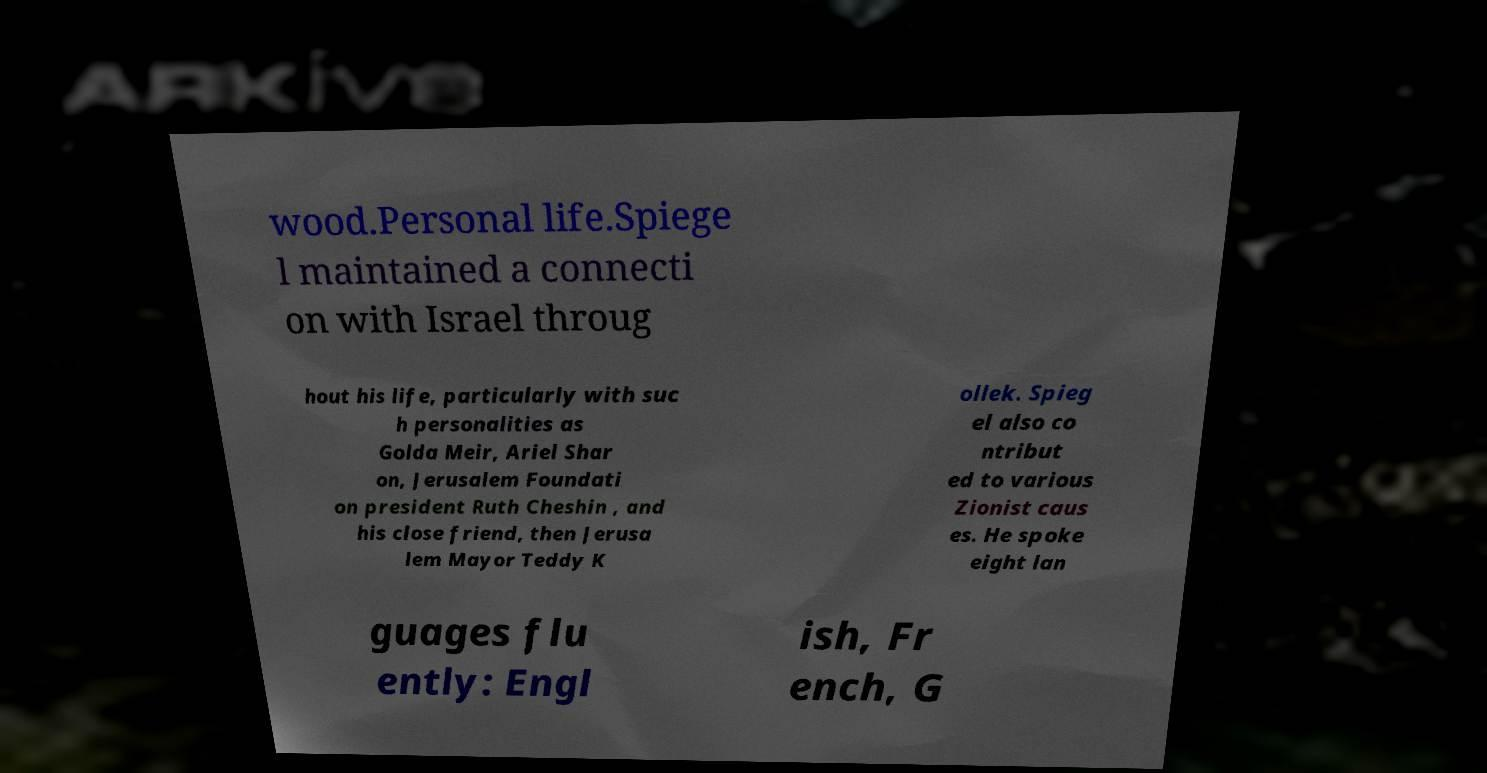Could you extract and type out the text from this image? wood.Personal life.Spiege l maintained a connecti on with Israel throug hout his life, particularly with suc h personalities as Golda Meir, Ariel Shar on, Jerusalem Foundati on president Ruth Cheshin , and his close friend, then Jerusa lem Mayor Teddy K ollek. Spieg el also co ntribut ed to various Zionist caus es. He spoke eight lan guages flu ently: Engl ish, Fr ench, G 